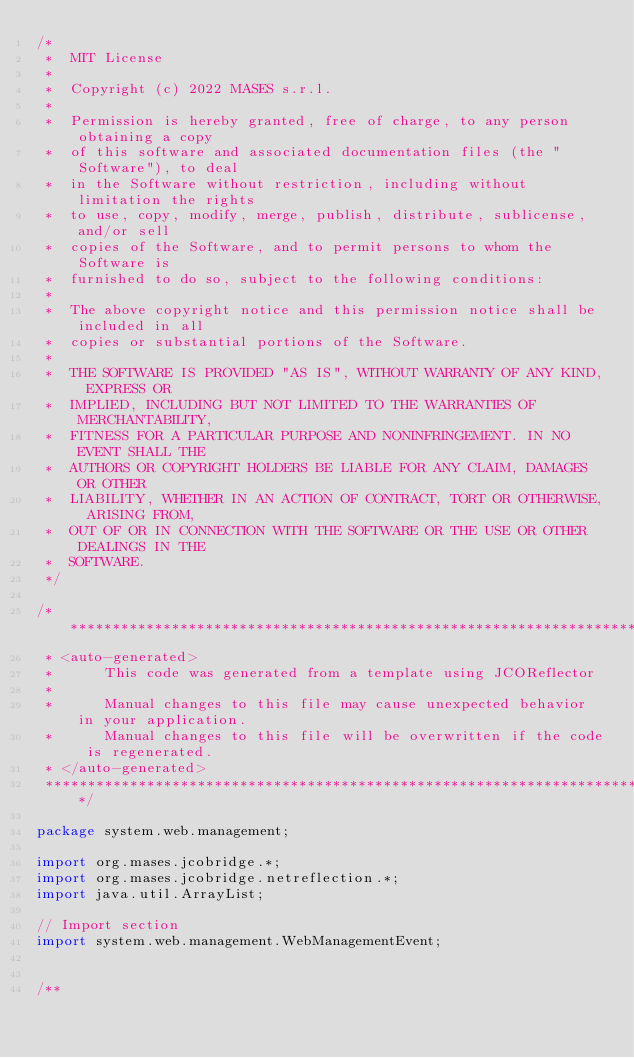<code> <loc_0><loc_0><loc_500><loc_500><_Java_>/*
 *  MIT License
 *
 *  Copyright (c) 2022 MASES s.r.l.
 *
 *  Permission is hereby granted, free of charge, to any person obtaining a copy
 *  of this software and associated documentation files (the "Software"), to deal
 *  in the Software without restriction, including without limitation the rights
 *  to use, copy, modify, merge, publish, distribute, sublicense, and/or sell
 *  copies of the Software, and to permit persons to whom the Software is
 *  furnished to do so, subject to the following conditions:
 *
 *  The above copyright notice and this permission notice shall be included in all
 *  copies or substantial portions of the Software.
 *
 *  THE SOFTWARE IS PROVIDED "AS IS", WITHOUT WARRANTY OF ANY KIND, EXPRESS OR
 *  IMPLIED, INCLUDING BUT NOT LIMITED TO THE WARRANTIES OF MERCHANTABILITY,
 *  FITNESS FOR A PARTICULAR PURPOSE AND NONINFRINGEMENT. IN NO EVENT SHALL THE
 *  AUTHORS OR COPYRIGHT HOLDERS BE LIABLE FOR ANY CLAIM, DAMAGES OR OTHER
 *  LIABILITY, WHETHER IN AN ACTION OF CONTRACT, TORT OR OTHERWISE, ARISING FROM,
 *  OUT OF OR IN CONNECTION WITH THE SOFTWARE OR THE USE OR OTHER DEALINGS IN THE
 *  SOFTWARE.
 */

/**************************************************************************************
 * <auto-generated>
 *      This code was generated from a template using JCOReflector
 * 
 *      Manual changes to this file may cause unexpected behavior in your application.
 *      Manual changes to this file will be overwritten if the code is regenerated.
 * </auto-generated>
 *************************************************************************************/

package system.web.management;

import org.mases.jcobridge.*;
import org.mases.jcobridge.netreflection.*;
import java.util.ArrayList;

// Import section
import system.web.management.WebManagementEvent;


/**</code> 